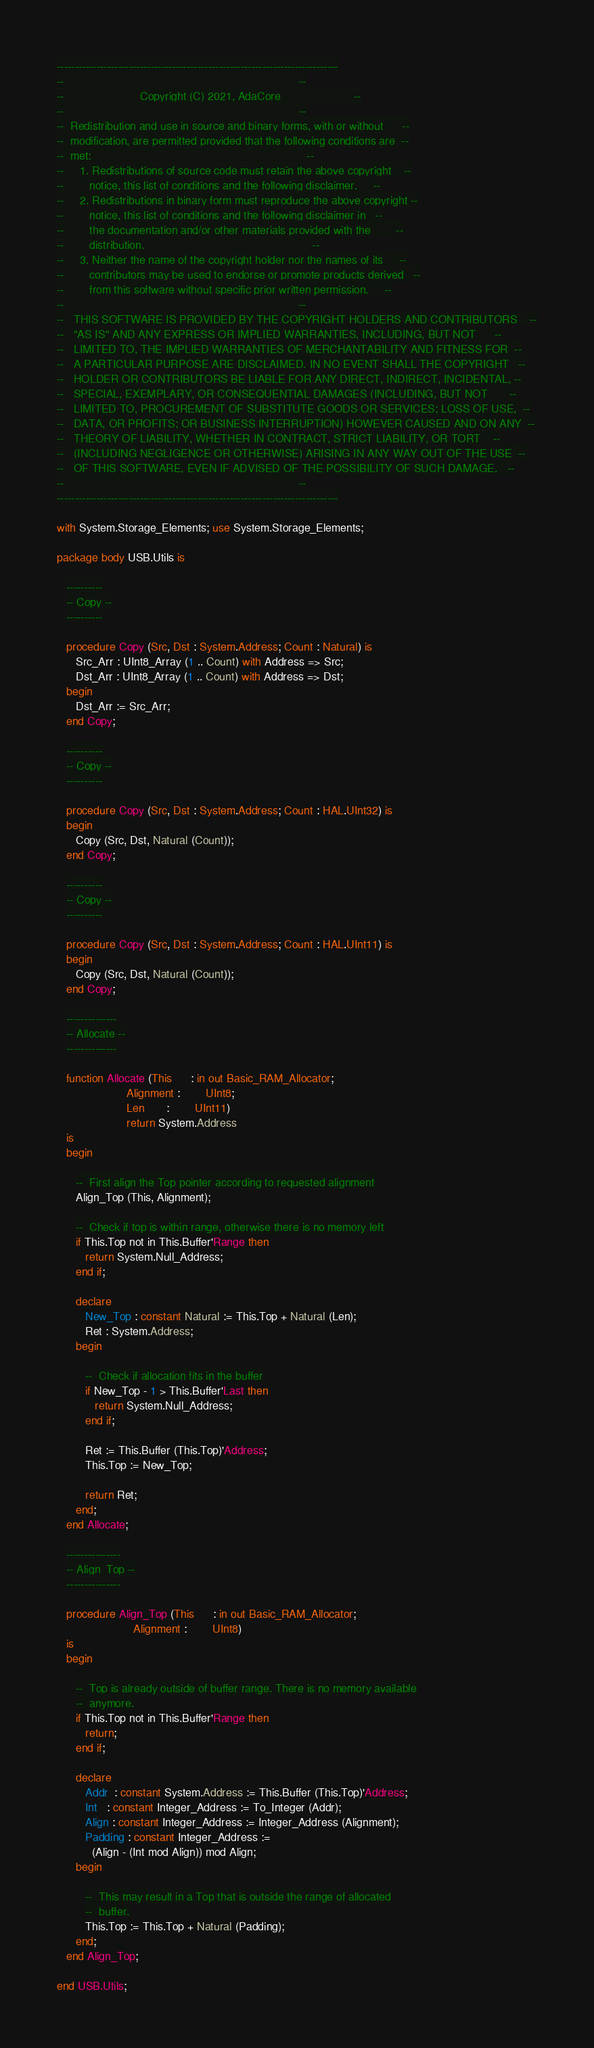<code> <loc_0><loc_0><loc_500><loc_500><_Ada_>------------------------------------------------------------------------------
--                                                                          --
--                        Copyright (C) 2021, AdaCore                       --
--                                                                          --
--  Redistribution and use in source and binary forms, with or without      --
--  modification, are permitted provided that the following conditions are  --
--  met:                                                                    --
--     1. Redistributions of source code must retain the above copyright    --
--        notice, this list of conditions and the following disclaimer.     --
--     2. Redistributions in binary form must reproduce the above copyright --
--        notice, this list of conditions and the following disclaimer in   --
--        the documentation and/or other materials provided with the        --
--        distribution.                                                     --
--     3. Neither the name of the copyright holder nor the names of its     --
--        contributors may be used to endorse or promote products derived   --
--        from this software without specific prior written permission.     --
--                                                                          --
--   THIS SOFTWARE IS PROVIDED BY THE COPYRIGHT HOLDERS AND CONTRIBUTORS    --
--   "AS IS" AND ANY EXPRESS OR IMPLIED WARRANTIES, INCLUDING, BUT NOT      --
--   LIMITED TO, THE IMPLIED WARRANTIES OF MERCHANTABILITY AND FITNESS FOR  --
--   A PARTICULAR PURPOSE ARE DISCLAIMED. IN NO EVENT SHALL THE COPYRIGHT   --
--   HOLDER OR CONTRIBUTORS BE LIABLE FOR ANY DIRECT, INDIRECT, INCIDENTAL, --
--   SPECIAL, EXEMPLARY, OR CONSEQUENTIAL DAMAGES (INCLUDING, BUT NOT       --
--   LIMITED TO, PROCUREMENT OF SUBSTITUTE GOODS OR SERVICES; LOSS OF USE,  --
--   DATA, OR PROFITS; OR BUSINESS INTERRUPTION) HOWEVER CAUSED AND ON ANY  --
--   THEORY OF LIABILITY, WHETHER IN CONTRACT, STRICT LIABILITY, OR TORT    --
--   (INCLUDING NEGLIGENCE OR OTHERWISE) ARISING IN ANY WAY OUT OF THE USE  --
--   OF THIS SOFTWARE, EVEN IF ADVISED OF THE POSSIBILITY OF SUCH DAMAGE.   --
--                                                                          --
------------------------------------------------------------------------------

with System.Storage_Elements; use System.Storage_Elements;

package body USB.Utils is

   ----------
   -- Copy --
   ----------

   procedure Copy (Src, Dst : System.Address; Count : Natural) is
      Src_Arr : UInt8_Array (1 .. Count) with Address => Src;
      Dst_Arr : UInt8_Array (1 .. Count) with Address => Dst;
   begin
      Dst_Arr := Src_Arr;
   end Copy;

   ----------
   -- Copy --
   ----------

   procedure Copy (Src, Dst : System.Address; Count : HAL.UInt32) is
   begin
      Copy (Src, Dst, Natural (Count));
   end Copy;

   ----------
   -- Copy --
   ----------

   procedure Copy (Src, Dst : System.Address; Count : HAL.UInt11) is
   begin
      Copy (Src, Dst, Natural (Count));
   end Copy;

   --------------
   -- Allocate --
   --------------

   function Allocate (This      : in out Basic_RAM_Allocator;
                      Alignment :        UInt8;
                      Len       :        UInt11)
                      return System.Address
   is
   begin

      --  First align the Top pointer according to requested alignment
      Align_Top (This, Alignment);

      --  Check if top is within range, otherwise there is no memory left
      if This.Top not in This.Buffer'Range then
         return System.Null_Address;
      end if;

      declare
         New_Top : constant Natural := This.Top + Natural (Len);
         Ret : System.Address;
      begin

         --  Check if allocation fits in the buffer
         if New_Top - 1 > This.Buffer'Last then
            return System.Null_Address;
         end if;

         Ret := This.Buffer (This.Top)'Address;
         This.Top := New_Top;

         return Ret;
      end;
   end Allocate;

   ---------------
   -- Align_Top --
   ---------------

   procedure Align_Top (This      : in out Basic_RAM_Allocator;
                        Alignment :        UInt8)
   is
   begin

      --  Top is already outside of buffer range. There is no memory available
      --  anymore.
      if This.Top not in This.Buffer'Range then
         return;
      end if;

      declare
         Addr  : constant System.Address := This.Buffer (This.Top)'Address;
         Int   : constant Integer_Address := To_Integer (Addr);
         Align : constant Integer_Address := Integer_Address (Alignment);
         Padding : constant Integer_Address :=
           (Align - (Int mod Align)) mod Align;
      begin

         --  This may result in a Top that is outside the range of allocated
         --  buffer.
         This.Top := This.Top + Natural (Padding);
      end;
   end Align_Top;

end USB.Utils;
</code> 